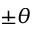<formula> <loc_0><loc_0><loc_500><loc_500>\pm \theta</formula> 